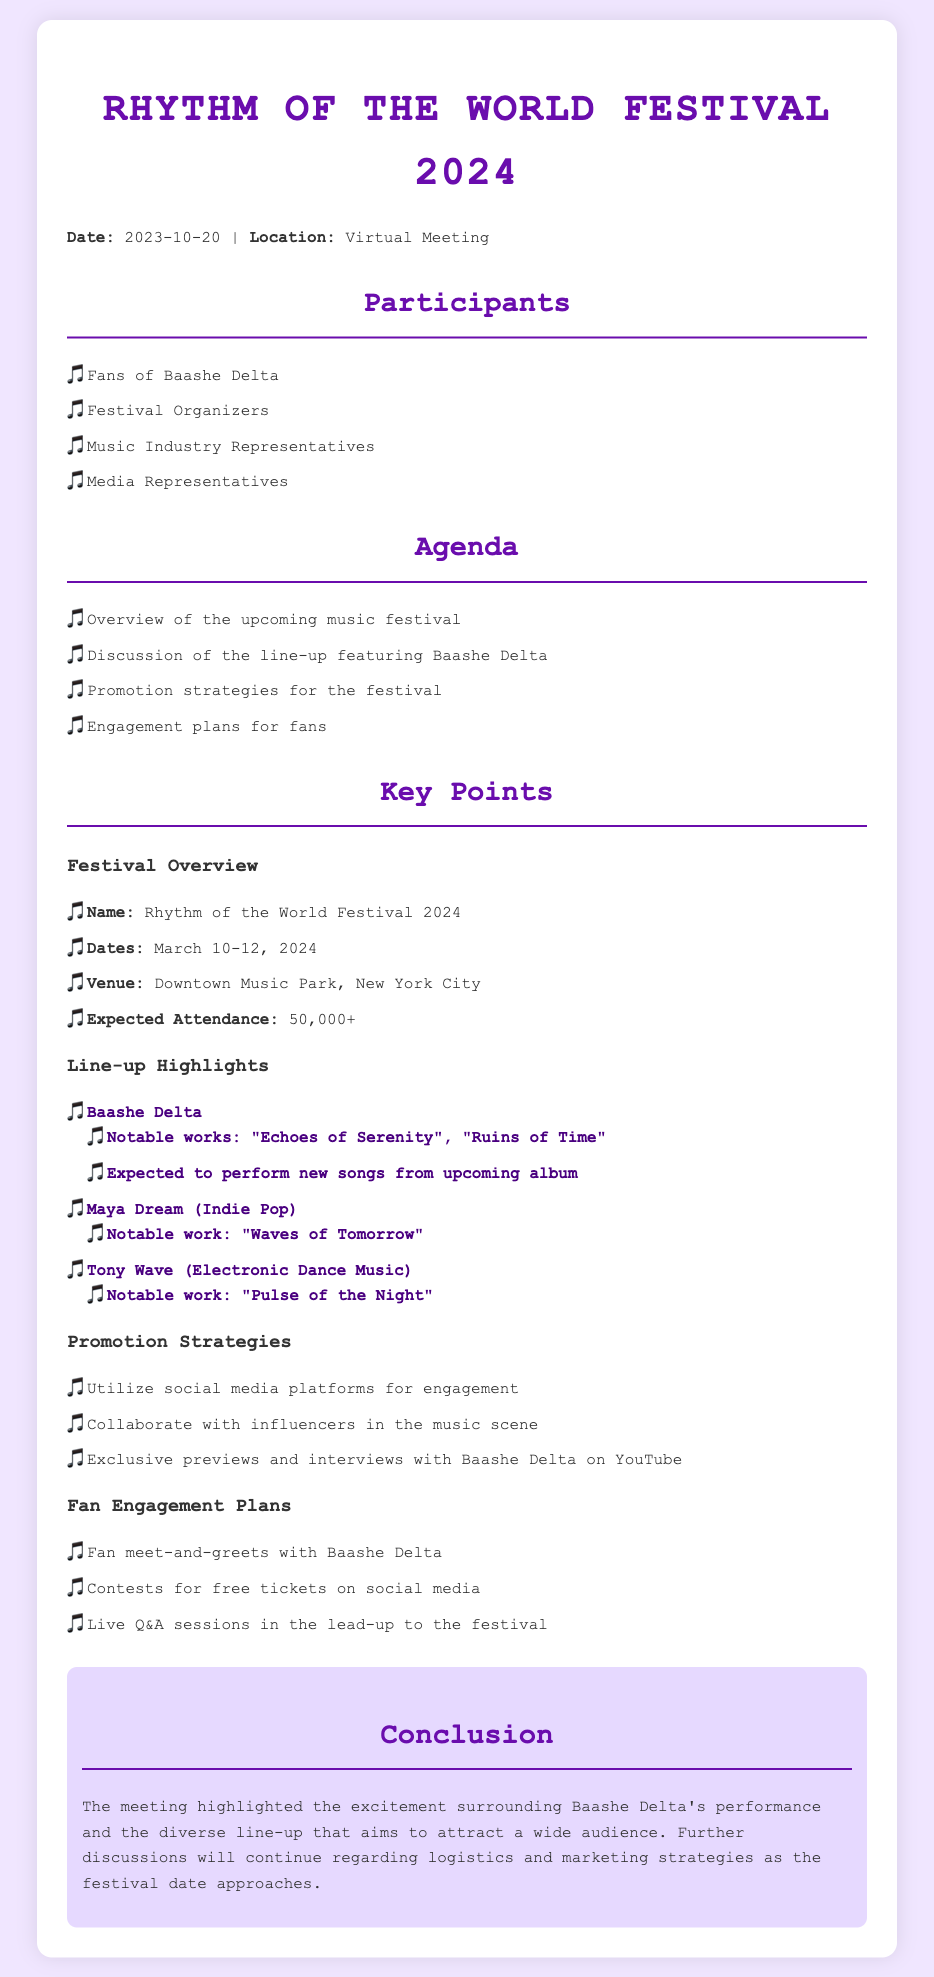What are the festival dates? The festival dates are explicitly mentioned in the document, which states March 10-12, 2024.
Answer: March 10-12, 2024 Who is headlining the festival? The document lists Baashe Delta prominently in the line-up highlights, indicating they are a featured artist.
Answer: Baashe Delta What is the expected attendance? The document notes that the expected attendance for the festival is over 50,000 attendees.
Answer: 50,000+ What notable works are mentioned for Baashe Delta? The document lists "Echoes of Serenity" and "Ruins of Time" as notable works of Baashe Delta.
Answer: "Echoes of Serenity", "Ruins of Time" What engagement plan includes meet-and-greets? The document specifies that there will be fan meet-and-greets with Baashe Delta as part of the engagement plans.
Answer: Fan meet-and-greets What is the venue for the festival? The venue for the festival, as stated in the document, is Downtown Music Park, New York City.
Answer: Downtown Music Park, New York City Which social media strategy is mentioned? The document outlines the use of social media platforms for engagement as a promotion strategy.
Answer: Use social media platforms What type of music does Tony Wave perform? The document categorizes Tony Wave as performing Electronic Dance Music.
Answer: Electronic Dance Music What are the festival overview and agenda items? The agenda includes an overview of the upcoming music festival, which highlights its name and date.
Answer: Overview of the upcoming music festival 